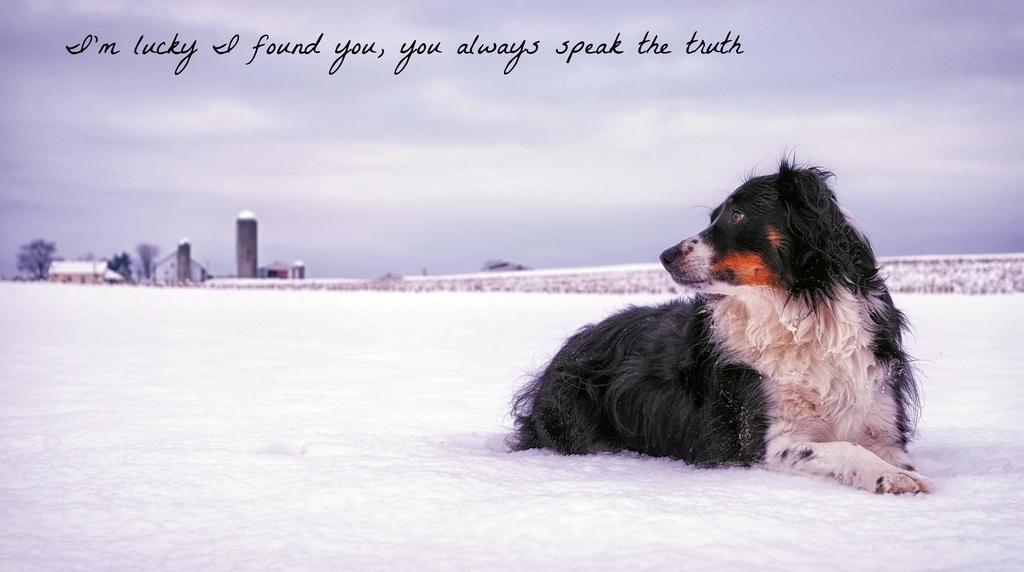Could you give a brief overview of what you see in this image? In this picture I can see a dog and snow on the ground and I can see buildings, trees and a cloudy sky and I can see text at the top of the picture. 